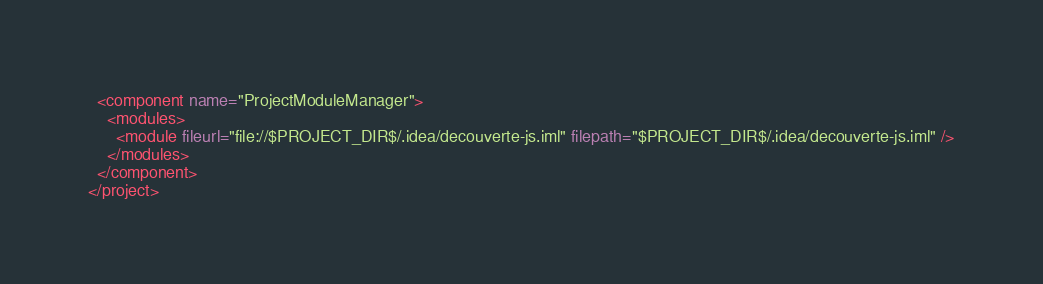Convert code to text. <code><loc_0><loc_0><loc_500><loc_500><_XML_>  <component name="ProjectModuleManager">
    <modules>
      <module fileurl="file://$PROJECT_DIR$/.idea/decouverte-js.iml" filepath="$PROJECT_DIR$/.idea/decouverte-js.iml" />
    </modules>
  </component>
</project></code> 